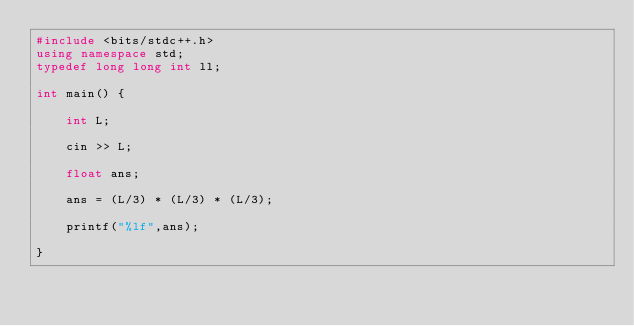<code> <loc_0><loc_0><loc_500><loc_500><_C++_>#include <bits/stdc++.h>
using namespace std;
typedef long long int ll;

int main() {

    int L;

    cin >> L;

    float ans;

    ans = (L/3) * (L/3) * (L/3);

    printf("%lf",ans);

}
</code> 